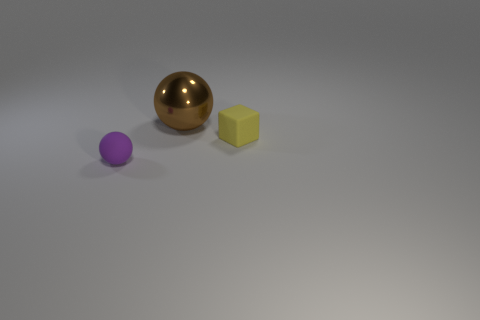Can you describe the colors of the objects shown? Certainly! There are three objects in the image, each with a distinct color. The spherical object has a shiny, metallic gold finish, the cube is a matte yellow, and the small, round object appears to be a solid purple. 